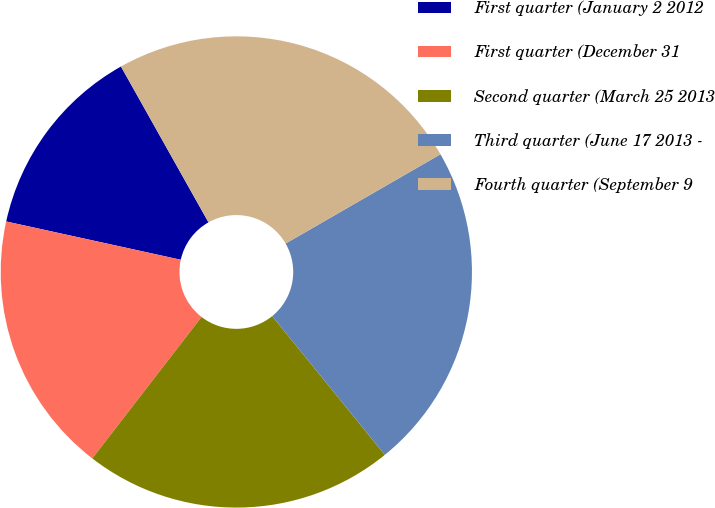Convert chart. <chart><loc_0><loc_0><loc_500><loc_500><pie_chart><fcel>First quarter (January 2 2012<fcel>First quarter (December 31<fcel>Second quarter (March 25 2013<fcel>Third quarter (June 17 2013 -<fcel>Fourth quarter (September 9<nl><fcel>13.42%<fcel>17.97%<fcel>21.32%<fcel>22.47%<fcel>24.82%<nl></chart> 